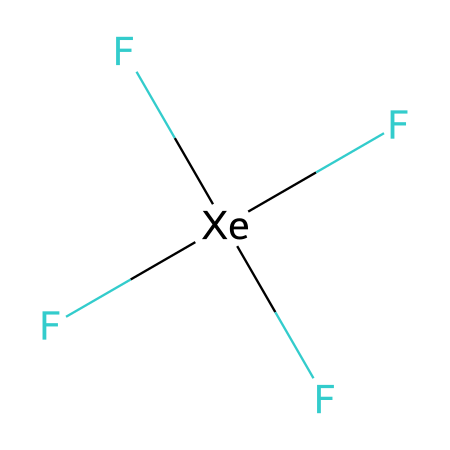What is the molecular formula of this compound? The SMILES notation indicates the presence of four fluorine (F) atoms bonded to a xenon (Xe) atom. Therefore, the molecular formula can be deduced as XeF4.
Answer: XeF4 How many fluorine atoms are bonded to the xenon atom? The structure shows that xenon is surrounded by four fluorine atoms attached through single bonds, as indicated by the notation F[Xe](F)(F)F. Therefore, there are four fluorine atoms.
Answer: 4 What is the steric number of xenon in this compound? The steric number is calculated by adding the number of bonding pairs (four fluorine atoms) to the number of lone pairs on xenon. Xenon has no lone pairs in this structure, hence the steric number is 4.
Answer: 4 What is the molecular geometry of xenon tetrafluoride? The molecular geometry for a molecule with a steric number of 4 and no lone pairs is square planar, which is characteristic of noble gas compounds involving hypervalency.
Answer: square planar How does the presence of fluorine atoms affect the stability of xenon tetrafluoride? The strong electronegativity of fluorine creates substantial polarization of the Xe-F bonds, making the compound more stable as compared to xenon-containing compounds without highly electronegative atoms. Thus, XeF4 is robust and stable.
Answer: stable What is the hybridization of the xenon atom in this compound? In xenon tetrafluoride, the xenon atom undergoes sp3d2 hybridization to accommodate the four bonding pairs with fluorine and form the square planar geometry.
Answer: sp3d2 Does xenon tetrafluoride exhibit hypervalency? Yes, xenon tetrafluoride is an example of a hypervalent compound as xenon can have more than eight electrons in its valence shell due to its d-orbitals.
Answer: Yes 